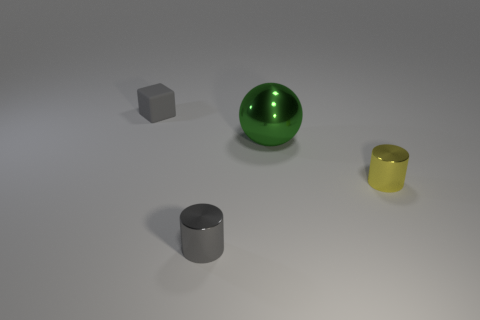Is there any other thing that has the same material as the small gray block?
Provide a short and direct response. No. Is there a metallic object of the same color as the tiny rubber cube?
Provide a succinct answer. Yes. How many things are big gray matte cubes or things to the right of the small cube?
Your answer should be very brief. 3. The tiny thing that is left of the tiny yellow metal object and in front of the gray block is made of what material?
Your answer should be compact. Metal. Are there any other things that are the same shape as the big green thing?
Provide a succinct answer. No. There is a cylinder that is made of the same material as the yellow object; what is its color?
Give a very brief answer. Gray. How many objects are either big green objects or small cylinders?
Offer a terse response. 3. Do the gray block and the metal cylinder in front of the yellow cylinder have the same size?
Your response must be concise. Yes. What color is the metal cylinder on the right side of the tiny gray object in front of the small metallic thing that is right of the big ball?
Give a very brief answer. Yellow. What is the color of the matte block?
Your response must be concise. Gray. 